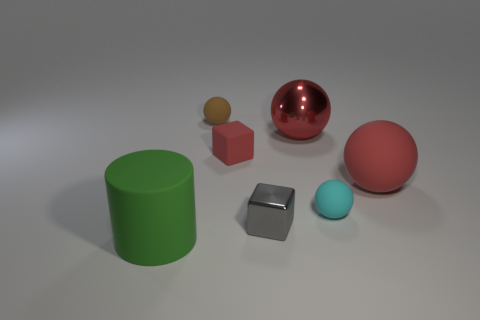What size is the cyan ball that is the same material as the small brown ball?
Give a very brief answer. Small. There is a rubber thing that is to the left of the brown ball; does it have the same size as the cyan thing?
Provide a succinct answer. No. Are there any yellow spheres of the same size as the red block?
Offer a very short reply. No. There is a large red thing behind the large ball that is in front of the metal ball; what is it made of?
Your answer should be very brief. Metal. How many large rubber cylinders are the same color as the big rubber ball?
Your answer should be very brief. 0. There is a tiny cyan object that is the same material as the green object; what is its shape?
Your response must be concise. Sphere. There is a shiny thing that is right of the tiny metallic object; how big is it?
Give a very brief answer. Large. Are there an equal number of large metallic objects that are to the right of the big metallic thing and small gray metal objects behind the small shiny block?
Provide a succinct answer. Yes. The tiny ball in front of the red rubber object that is left of the tiny matte object in front of the small red object is what color?
Make the answer very short. Cyan. What number of things are to the right of the brown object and behind the tiny gray metallic thing?
Give a very brief answer. 4. 